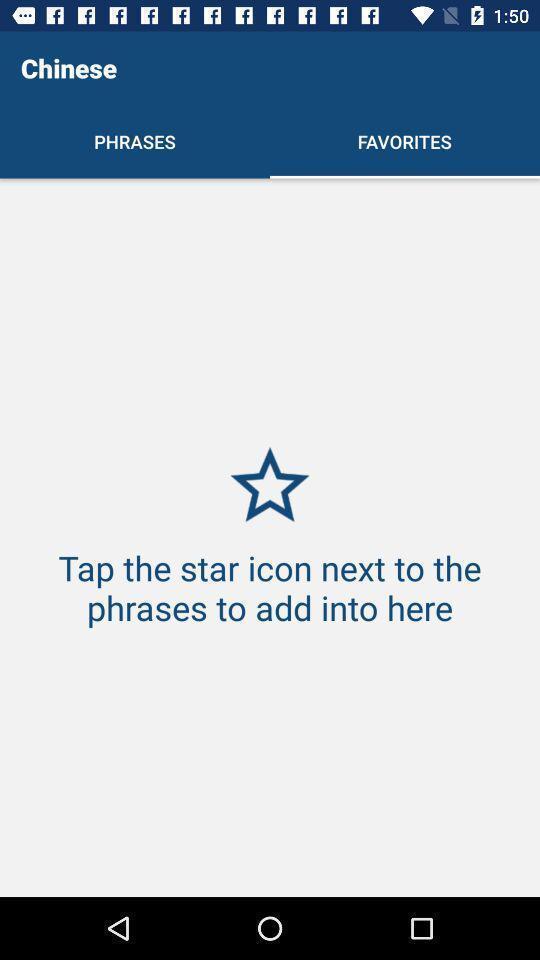What is the overall content of this screenshot? Page showing a favorites. 